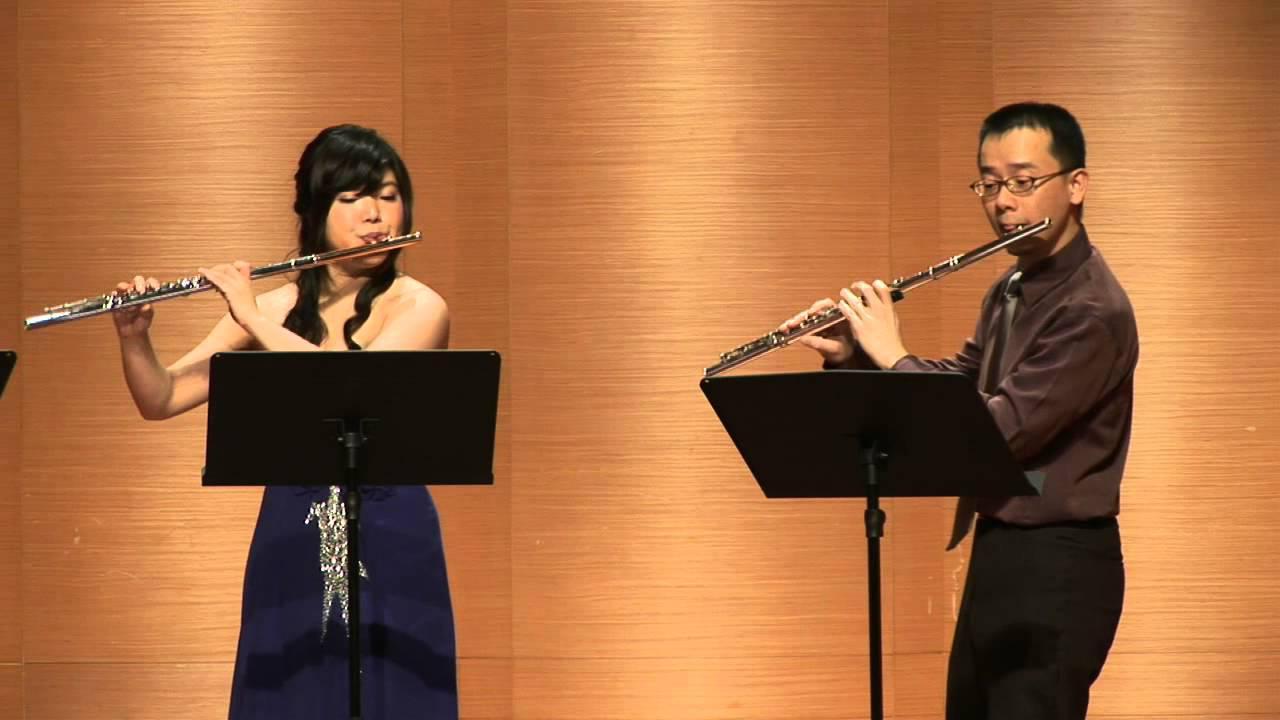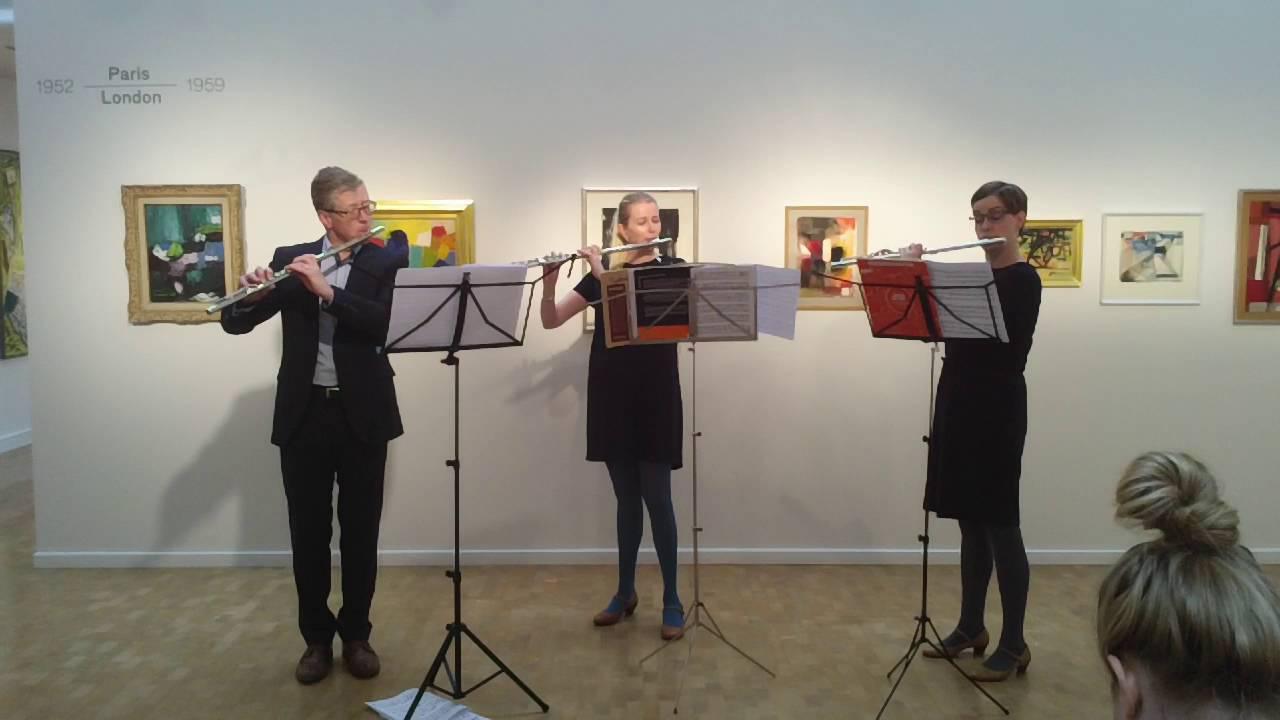The first image is the image on the left, the second image is the image on the right. Examine the images to the left and right. Is the description "There are three women in black dresses  looking at sheet music while playing the flute" accurate? Answer yes or no. No. The first image is the image on the left, the second image is the image on the right. Evaluate the accuracy of this statement regarding the images: "There are six flutists standing.". Is it true? Answer yes or no. No. 